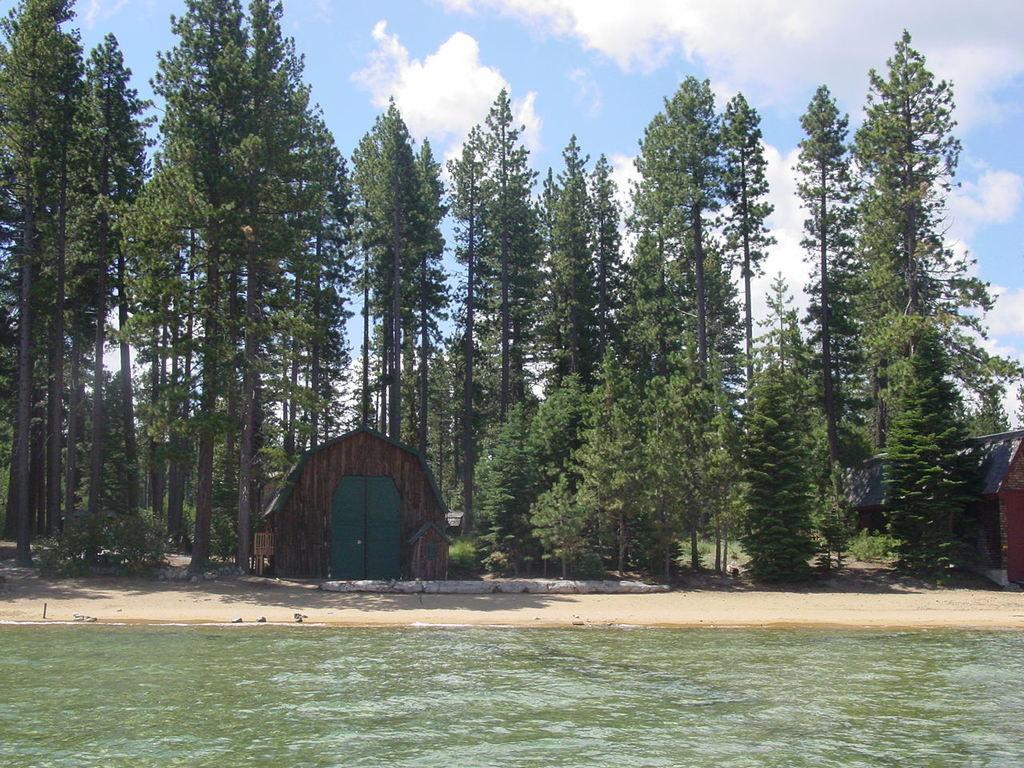In one or two sentences, can you explain what this image depicts? In this picture we can see the watersheds, trees and some objects and in the background we can see the sky with clouds. 